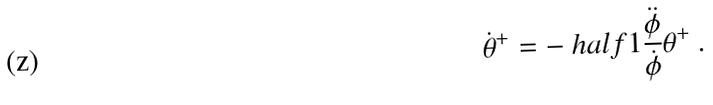<formula> <loc_0><loc_0><loc_500><loc_500>\dot { \theta } ^ { + } = - \ h a l f { 1 } \frac { \ddot { \phi } } { \dot { \phi } } \theta ^ { + } \ .</formula> 